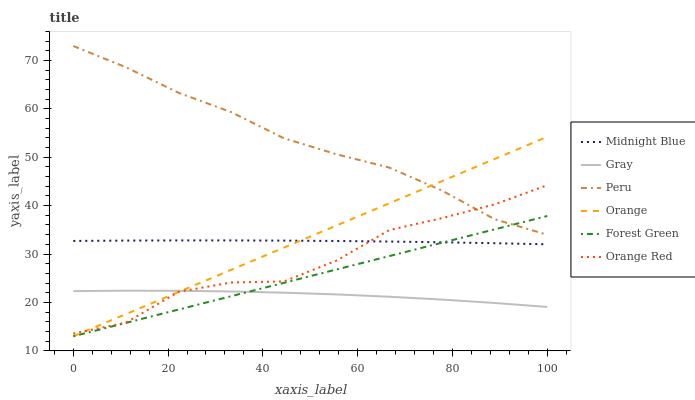Does Gray have the minimum area under the curve?
Answer yes or no. Yes. Does Peru have the maximum area under the curve?
Answer yes or no. Yes. Does Midnight Blue have the minimum area under the curve?
Answer yes or no. No. Does Midnight Blue have the maximum area under the curve?
Answer yes or no. No. Is Forest Green the smoothest?
Answer yes or no. Yes. Is Orange Red the roughest?
Answer yes or no. Yes. Is Midnight Blue the smoothest?
Answer yes or no. No. Is Midnight Blue the roughest?
Answer yes or no. No. Does Midnight Blue have the lowest value?
Answer yes or no. No. Does Peru have the highest value?
Answer yes or no. Yes. Does Midnight Blue have the highest value?
Answer yes or no. No. Is Midnight Blue less than Peru?
Answer yes or no. Yes. Is Orange Red greater than Forest Green?
Answer yes or no. Yes. Does Midnight Blue intersect Orange?
Answer yes or no. Yes. Is Midnight Blue less than Orange?
Answer yes or no. No. Is Midnight Blue greater than Orange?
Answer yes or no. No. Does Midnight Blue intersect Peru?
Answer yes or no. No. 